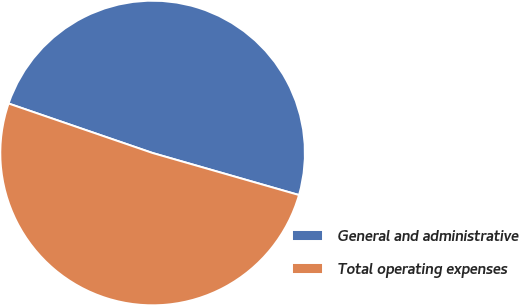Convert chart to OTSL. <chart><loc_0><loc_0><loc_500><loc_500><pie_chart><fcel>General and administrative<fcel>Total operating expenses<nl><fcel>49.18%<fcel>50.82%<nl></chart> 